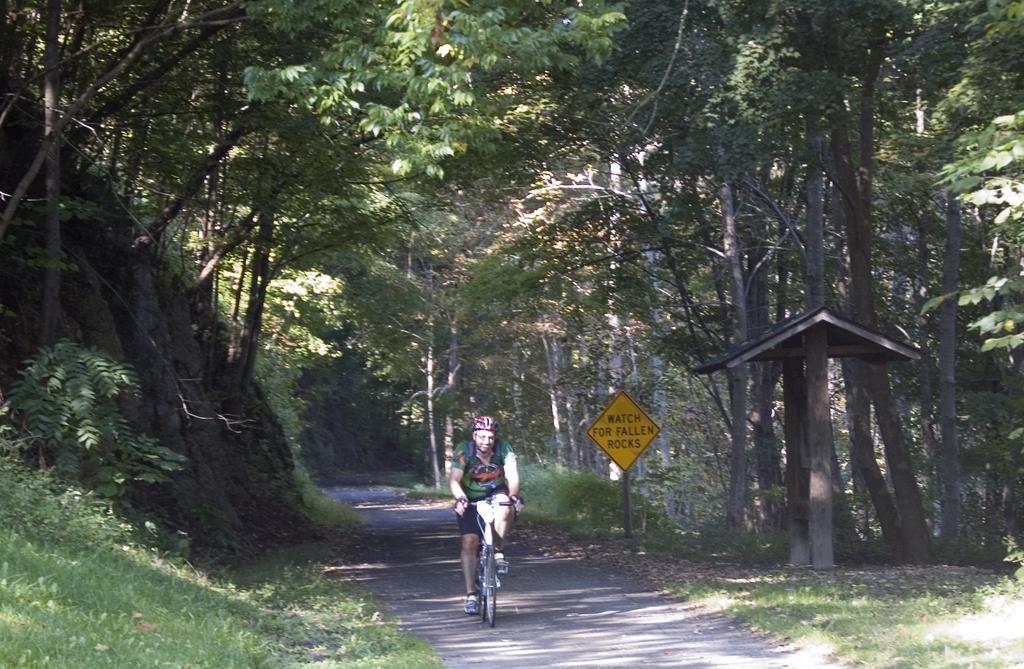Please provide a concise description of this image. In the foreground I can see a person is riding a bicycle on the road, grass, board and a shed. In the background I can see trees. This image is taken may be during a sunny day. 